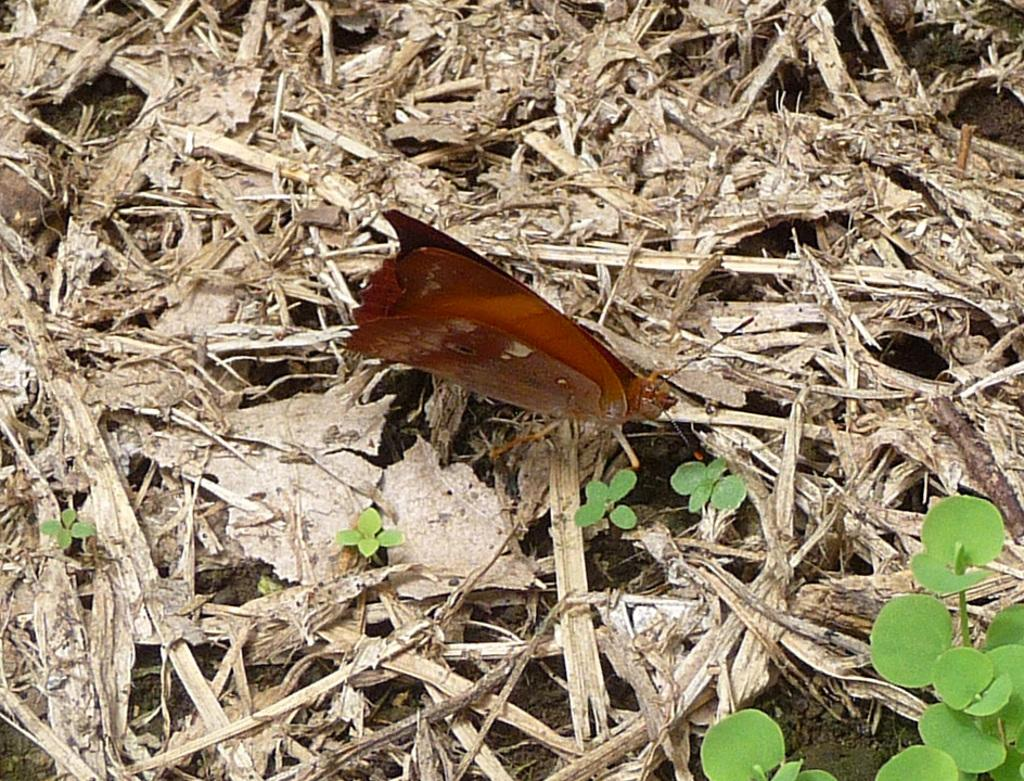What is there is a butterfly on the ground in the image, what is its location? The butterfly is on the ground in the image. What else can be seen in the image besides the butterfly? There are plants in the image. Can you see any ducks swimming in the cream on the coast in the image? There is no coast, duck, or cream present in the image; it features a butterfly on the ground and plants. 